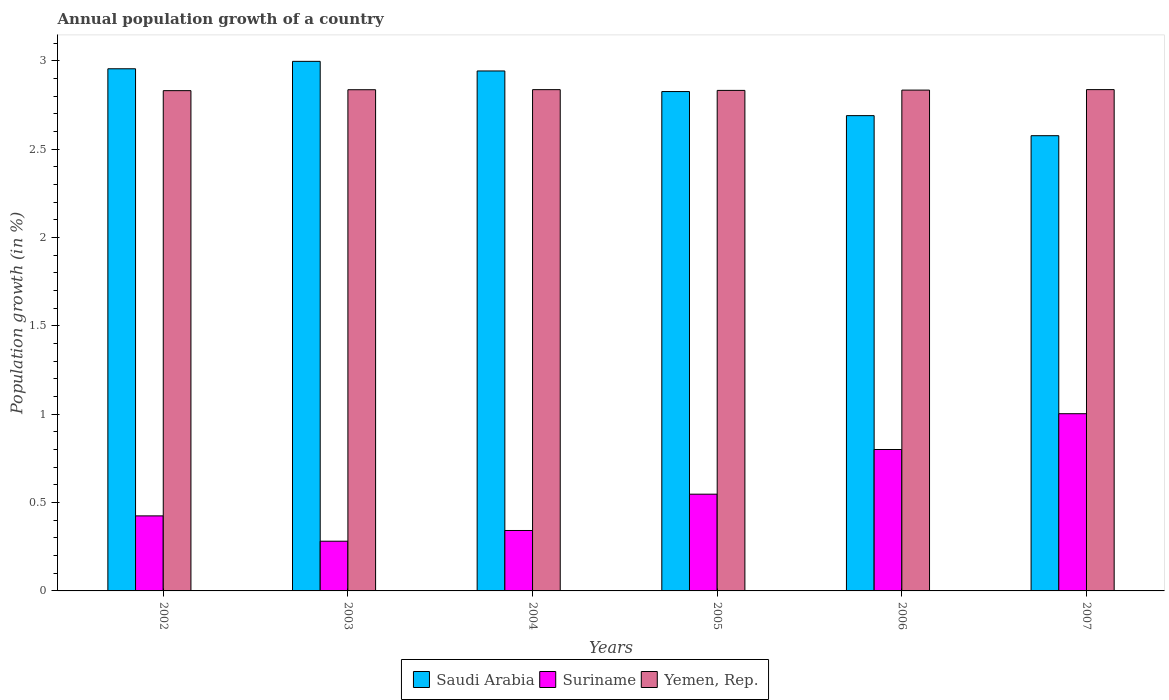Are the number of bars per tick equal to the number of legend labels?
Offer a terse response. Yes. How many bars are there on the 3rd tick from the left?
Provide a short and direct response. 3. How many bars are there on the 2nd tick from the right?
Keep it short and to the point. 3. In how many cases, is the number of bars for a given year not equal to the number of legend labels?
Provide a short and direct response. 0. What is the annual population growth in Suriname in 2003?
Your response must be concise. 0.28. Across all years, what is the maximum annual population growth in Saudi Arabia?
Ensure brevity in your answer.  3. Across all years, what is the minimum annual population growth in Yemen, Rep.?
Provide a succinct answer. 2.83. In which year was the annual population growth in Suriname maximum?
Provide a succinct answer. 2007. What is the total annual population growth in Yemen, Rep. in the graph?
Give a very brief answer. 17.01. What is the difference between the annual population growth in Saudi Arabia in 2004 and that in 2006?
Provide a short and direct response. 0.25. What is the difference between the annual population growth in Saudi Arabia in 2005 and the annual population growth in Suriname in 2006?
Give a very brief answer. 2.03. What is the average annual population growth in Saudi Arabia per year?
Provide a succinct answer. 2.83. In the year 2006, what is the difference between the annual population growth in Suriname and annual population growth in Yemen, Rep.?
Ensure brevity in your answer.  -2.03. What is the ratio of the annual population growth in Yemen, Rep. in 2005 to that in 2006?
Your answer should be very brief. 1. Is the annual population growth in Saudi Arabia in 2002 less than that in 2004?
Give a very brief answer. No. What is the difference between the highest and the second highest annual population growth in Saudi Arabia?
Offer a very short reply. 0.04. What is the difference between the highest and the lowest annual population growth in Saudi Arabia?
Your answer should be compact. 0.42. Is the sum of the annual population growth in Yemen, Rep. in 2003 and 2005 greater than the maximum annual population growth in Suriname across all years?
Offer a very short reply. Yes. What does the 2nd bar from the left in 2002 represents?
Keep it short and to the point. Suriname. What does the 3rd bar from the right in 2002 represents?
Your answer should be very brief. Saudi Arabia. How many years are there in the graph?
Provide a succinct answer. 6. What is the difference between two consecutive major ticks on the Y-axis?
Make the answer very short. 0.5. Are the values on the major ticks of Y-axis written in scientific E-notation?
Provide a succinct answer. No. Does the graph contain any zero values?
Provide a short and direct response. No. Does the graph contain grids?
Your answer should be compact. No. Where does the legend appear in the graph?
Your answer should be very brief. Bottom center. How are the legend labels stacked?
Offer a terse response. Horizontal. What is the title of the graph?
Ensure brevity in your answer.  Annual population growth of a country. Does "Suriname" appear as one of the legend labels in the graph?
Ensure brevity in your answer.  Yes. What is the label or title of the X-axis?
Offer a very short reply. Years. What is the label or title of the Y-axis?
Your response must be concise. Population growth (in %). What is the Population growth (in %) of Saudi Arabia in 2002?
Make the answer very short. 2.96. What is the Population growth (in %) of Suriname in 2002?
Your answer should be compact. 0.42. What is the Population growth (in %) of Yemen, Rep. in 2002?
Provide a succinct answer. 2.83. What is the Population growth (in %) in Saudi Arabia in 2003?
Provide a succinct answer. 3. What is the Population growth (in %) in Suriname in 2003?
Offer a very short reply. 0.28. What is the Population growth (in %) of Yemen, Rep. in 2003?
Offer a very short reply. 2.84. What is the Population growth (in %) in Saudi Arabia in 2004?
Give a very brief answer. 2.94. What is the Population growth (in %) of Suriname in 2004?
Your answer should be very brief. 0.34. What is the Population growth (in %) in Yemen, Rep. in 2004?
Keep it short and to the point. 2.84. What is the Population growth (in %) in Saudi Arabia in 2005?
Your answer should be very brief. 2.83. What is the Population growth (in %) in Suriname in 2005?
Ensure brevity in your answer.  0.55. What is the Population growth (in %) in Yemen, Rep. in 2005?
Provide a succinct answer. 2.83. What is the Population growth (in %) in Saudi Arabia in 2006?
Give a very brief answer. 2.69. What is the Population growth (in %) of Suriname in 2006?
Give a very brief answer. 0.8. What is the Population growth (in %) of Yemen, Rep. in 2006?
Give a very brief answer. 2.83. What is the Population growth (in %) in Saudi Arabia in 2007?
Offer a terse response. 2.58. What is the Population growth (in %) in Suriname in 2007?
Offer a very short reply. 1. What is the Population growth (in %) in Yemen, Rep. in 2007?
Keep it short and to the point. 2.84. Across all years, what is the maximum Population growth (in %) of Saudi Arabia?
Ensure brevity in your answer.  3. Across all years, what is the maximum Population growth (in %) of Suriname?
Offer a terse response. 1. Across all years, what is the maximum Population growth (in %) in Yemen, Rep.?
Give a very brief answer. 2.84. Across all years, what is the minimum Population growth (in %) in Saudi Arabia?
Make the answer very short. 2.58. Across all years, what is the minimum Population growth (in %) of Suriname?
Provide a short and direct response. 0.28. Across all years, what is the minimum Population growth (in %) of Yemen, Rep.?
Your response must be concise. 2.83. What is the total Population growth (in %) in Saudi Arabia in the graph?
Your response must be concise. 16.99. What is the total Population growth (in %) in Suriname in the graph?
Your response must be concise. 3.4. What is the total Population growth (in %) in Yemen, Rep. in the graph?
Offer a terse response. 17.01. What is the difference between the Population growth (in %) in Saudi Arabia in 2002 and that in 2003?
Make the answer very short. -0.04. What is the difference between the Population growth (in %) of Suriname in 2002 and that in 2003?
Make the answer very short. 0.14. What is the difference between the Population growth (in %) in Yemen, Rep. in 2002 and that in 2003?
Keep it short and to the point. -0.01. What is the difference between the Population growth (in %) in Saudi Arabia in 2002 and that in 2004?
Offer a terse response. 0.01. What is the difference between the Population growth (in %) of Suriname in 2002 and that in 2004?
Make the answer very short. 0.08. What is the difference between the Population growth (in %) in Yemen, Rep. in 2002 and that in 2004?
Keep it short and to the point. -0.01. What is the difference between the Population growth (in %) of Saudi Arabia in 2002 and that in 2005?
Give a very brief answer. 0.13. What is the difference between the Population growth (in %) in Suriname in 2002 and that in 2005?
Your answer should be very brief. -0.12. What is the difference between the Population growth (in %) of Yemen, Rep. in 2002 and that in 2005?
Make the answer very short. -0. What is the difference between the Population growth (in %) in Saudi Arabia in 2002 and that in 2006?
Offer a terse response. 0.27. What is the difference between the Population growth (in %) in Suriname in 2002 and that in 2006?
Your response must be concise. -0.38. What is the difference between the Population growth (in %) in Yemen, Rep. in 2002 and that in 2006?
Provide a succinct answer. -0. What is the difference between the Population growth (in %) of Saudi Arabia in 2002 and that in 2007?
Offer a terse response. 0.38. What is the difference between the Population growth (in %) of Suriname in 2002 and that in 2007?
Ensure brevity in your answer.  -0.58. What is the difference between the Population growth (in %) in Yemen, Rep. in 2002 and that in 2007?
Your response must be concise. -0.01. What is the difference between the Population growth (in %) in Saudi Arabia in 2003 and that in 2004?
Ensure brevity in your answer.  0.05. What is the difference between the Population growth (in %) in Suriname in 2003 and that in 2004?
Your response must be concise. -0.06. What is the difference between the Population growth (in %) in Yemen, Rep. in 2003 and that in 2004?
Ensure brevity in your answer.  -0. What is the difference between the Population growth (in %) of Saudi Arabia in 2003 and that in 2005?
Keep it short and to the point. 0.17. What is the difference between the Population growth (in %) in Suriname in 2003 and that in 2005?
Your answer should be compact. -0.27. What is the difference between the Population growth (in %) of Yemen, Rep. in 2003 and that in 2005?
Ensure brevity in your answer.  0. What is the difference between the Population growth (in %) of Saudi Arabia in 2003 and that in 2006?
Make the answer very short. 0.31. What is the difference between the Population growth (in %) in Suriname in 2003 and that in 2006?
Your answer should be very brief. -0.52. What is the difference between the Population growth (in %) of Yemen, Rep. in 2003 and that in 2006?
Ensure brevity in your answer.  0. What is the difference between the Population growth (in %) of Saudi Arabia in 2003 and that in 2007?
Ensure brevity in your answer.  0.42. What is the difference between the Population growth (in %) of Suriname in 2003 and that in 2007?
Offer a terse response. -0.72. What is the difference between the Population growth (in %) in Yemen, Rep. in 2003 and that in 2007?
Provide a succinct answer. -0. What is the difference between the Population growth (in %) in Saudi Arabia in 2004 and that in 2005?
Give a very brief answer. 0.12. What is the difference between the Population growth (in %) in Suriname in 2004 and that in 2005?
Offer a terse response. -0.21. What is the difference between the Population growth (in %) of Yemen, Rep. in 2004 and that in 2005?
Keep it short and to the point. 0. What is the difference between the Population growth (in %) in Saudi Arabia in 2004 and that in 2006?
Keep it short and to the point. 0.25. What is the difference between the Population growth (in %) of Suriname in 2004 and that in 2006?
Your answer should be very brief. -0.46. What is the difference between the Population growth (in %) in Yemen, Rep. in 2004 and that in 2006?
Provide a succinct answer. 0. What is the difference between the Population growth (in %) of Saudi Arabia in 2004 and that in 2007?
Your answer should be compact. 0.37. What is the difference between the Population growth (in %) of Suriname in 2004 and that in 2007?
Offer a terse response. -0.66. What is the difference between the Population growth (in %) of Yemen, Rep. in 2004 and that in 2007?
Ensure brevity in your answer.  -0. What is the difference between the Population growth (in %) of Saudi Arabia in 2005 and that in 2006?
Keep it short and to the point. 0.14. What is the difference between the Population growth (in %) in Suriname in 2005 and that in 2006?
Provide a short and direct response. -0.25. What is the difference between the Population growth (in %) of Yemen, Rep. in 2005 and that in 2006?
Your response must be concise. -0. What is the difference between the Population growth (in %) of Saudi Arabia in 2005 and that in 2007?
Keep it short and to the point. 0.25. What is the difference between the Population growth (in %) of Suriname in 2005 and that in 2007?
Your answer should be very brief. -0.46. What is the difference between the Population growth (in %) in Yemen, Rep. in 2005 and that in 2007?
Ensure brevity in your answer.  -0. What is the difference between the Population growth (in %) of Saudi Arabia in 2006 and that in 2007?
Provide a short and direct response. 0.11. What is the difference between the Population growth (in %) of Suriname in 2006 and that in 2007?
Provide a succinct answer. -0.2. What is the difference between the Population growth (in %) of Yemen, Rep. in 2006 and that in 2007?
Provide a short and direct response. -0. What is the difference between the Population growth (in %) of Saudi Arabia in 2002 and the Population growth (in %) of Suriname in 2003?
Make the answer very short. 2.67. What is the difference between the Population growth (in %) in Saudi Arabia in 2002 and the Population growth (in %) in Yemen, Rep. in 2003?
Keep it short and to the point. 0.12. What is the difference between the Population growth (in %) of Suriname in 2002 and the Population growth (in %) of Yemen, Rep. in 2003?
Give a very brief answer. -2.41. What is the difference between the Population growth (in %) of Saudi Arabia in 2002 and the Population growth (in %) of Suriname in 2004?
Provide a short and direct response. 2.61. What is the difference between the Population growth (in %) in Saudi Arabia in 2002 and the Population growth (in %) in Yemen, Rep. in 2004?
Offer a very short reply. 0.12. What is the difference between the Population growth (in %) of Suriname in 2002 and the Population growth (in %) of Yemen, Rep. in 2004?
Your response must be concise. -2.41. What is the difference between the Population growth (in %) of Saudi Arabia in 2002 and the Population growth (in %) of Suriname in 2005?
Provide a succinct answer. 2.41. What is the difference between the Population growth (in %) in Saudi Arabia in 2002 and the Population growth (in %) in Yemen, Rep. in 2005?
Provide a short and direct response. 0.12. What is the difference between the Population growth (in %) in Suriname in 2002 and the Population growth (in %) in Yemen, Rep. in 2005?
Your answer should be compact. -2.41. What is the difference between the Population growth (in %) in Saudi Arabia in 2002 and the Population growth (in %) in Suriname in 2006?
Ensure brevity in your answer.  2.16. What is the difference between the Population growth (in %) of Saudi Arabia in 2002 and the Population growth (in %) of Yemen, Rep. in 2006?
Offer a terse response. 0.12. What is the difference between the Population growth (in %) of Suriname in 2002 and the Population growth (in %) of Yemen, Rep. in 2006?
Your answer should be compact. -2.41. What is the difference between the Population growth (in %) in Saudi Arabia in 2002 and the Population growth (in %) in Suriname in 2007?
Make the answer very short. 1.95. What is the difference between the Population growth (in %) in Saudi Arabia in 2002 and the Population growth (in %) in Yemen, Rep. in 2007?
Give a very brief answer. 0.12. What is the difference between the Population growth (in %) in Suriname in 2002 and the Population growth (in %) in Yemen, Rep. in 2007?
Provide a succinct answer. -2.41. What is the difference between the Population growth (in %) in Saudi Arabia in 2003 and the Population growth (in %) in Suriname in 2004?
Offer a terse response. 2.66. What is the difference between the Population growth (in %) in Saudi Arabia in 2003 and the Population growth (in %) in Yemen, Rep. in 2004?
Keep it short and to the point. 0.16. What is the difference between the Population growth (in %) of Suriname in 2003 and the Population growth (in %) of Yemen, Rep. in 2004?
Your answer should be compact. -2.56. What is the difference between the Population growth (in %) in Saudi Arabia in 2003 and the Population growth (in %) in Suriname in 2005?
Ensure brevity in your answer.  2.45. What is the difference between the Population growth (in %) of Saudi Arabia in 2003 and the Population growth (in %) of Yemen, Rep. in 2005?
Your answer should be compact. 0.16. What is the difference between the Population growth (in %) in Suriname in 2003 and the Population growth (in %) in Yemen, Rep. in 2005?
Provide a succinct answer. -2.55. What is the difference between the Population growth (in %) in Saudi Arabia in 2003 and the Population growth (in %) in Suriname in 2006?
Provide a succinct answer. 2.2. What is the difference between the Population growth (in %) of Saudi Arabia in 2003 and the Population growth (in %) of Yemen, Rep. in 2006?
Keep it short and to the point. 0.16. What is the difference between the Population growth (in %) of Suriname in 2003 and the Population growth (in %) of Yemen, Rep. in 2006?
Give a very brief answer. -2.55. What is the difference between the Population growth (in %) in Saudi Arabia in 2003 and the Population growth (in %) in Suriname in 2007?
Provide a short and direct response. 1.99. What is the difference between the Population growth (in %) in Saudi Arabia in 2003 and the Population growth (in %) in Yemen, Rep. in 2007?
Offer a very short reply. 0.16. What is the difference between the Population growth (in %) of Suriname in 2003 and the Population growth (in %) of Yemen, Rep. in 2007?
Ensure brevity in your answer.  -2.56. What is the difference between the Population growth (in %) of Saudi Arabia in 2004 and the Population growth (in %) of Suriname in 2005?
Make the answer very short. 2.4. What is the difference between the Population growth (in %) of Saudi Arabia in 2004 and the Population growth (in %) of Yemen, Rep. in 2005?
Offer a terse response. 0.11. What is the difference between the Population growth (in %) in Suriname in 2004 and the Population growth (in %) in Yemen, Rep. in 2005?
Provide a short and direct response. -2.49. What is the difference between the Population growth (in %) of Saudi Arabia in 2004 and the Population growth (in %) of Suriname in 2006?
Your response must be concise. 2.14. What is the difference between the Population growth (in %) in Saudi Arabia in 2004 and the Population growth (in %) in Yemen, Rep. in 2006?
Ensure brevity in your answer.  0.11. What is the difference between the Population growth (in %) in Suriname in 2004 and the Population growth (in %) in Yemen, Rep. in 2006?
Offer a very short reply. -2.49. What is the difference between the Population growth (in %) in Saudi Arabia in 2004 and the Population growth (in %) in Suriname in 2007?
Your response must be concise. 1.94. What is the difference between the Population growth (in %) in Saudi Arabia in 2004 and the Population growth (in %) in Yemen, Rep. in 2007?
Offer a terse response. 0.11. What is the difference between the Population growth (in %) of Suriname in 2004 and the Population growth (in %) of Yemen, Rep. in 2007?
Ensure brevity in your answer.  -2.5. What is the difference between the Population growth (in %) of Saudi Arabia in 2005 and the Population growth (in %) of Suriname in 2006?
Offer a terse response. 2.03. What is the difference between the Population growth (in %) in Saudi Arabia in 2005 and the Population growth (in %) in Yemen, Rep. in 2006?
Your answer should be very brief. -0.01. What is the difference between the Population growth (in %) in Suriname in 2005 and the Population growth (in %) in Yemen, Rep. in 2006?
Offer a terse response. -2.29. What is the difference between the Population growth (in %) in Saudi Arabia in 2005 and the Population growth (in %) in Suriname in 2007?
Give a very brief answer. 1.82. What is the difference between the Population growth (in %) of Saudi Arabia in 2005 and the Population growth (in %) of Yemen, Rep. in 2007?
Give a very brief answer. -0.01. What is the difference between the Population growth (in %) in Suriname in 2005 and the Population growth (in %) in Yemen, Rep. in 2007?
Offer a terse response. -2.29. What is the difference between the Population growth (in %) in Saudi Arabia in 2006 and the Population growth (in %) in Suriname in 2007?
Your answer should be very brief. 1.69. What is the difference between the Population growth (in %) of Saudi Arabia in 2006 and the Population growth (in %) of Yemen, Rep. in 2007?
Provide a short and direct response. -0.15. What is the difference between the Population growth (in %) in Suriname in 2006 and the Population growth (in %) in Yemen, Rep. in 2007?
Provide a succinct answer. -2.04. What is the average Population growth (in %) in Saudi Arabia per year?
Your response must be concise. 2.83. What is the average Population growth (in %) of Suriname per year?
Keep it short and to the point. 0.57. What is the average Population growth (in %) in Yemen, Rep. per year?
Your answer should be compact. 2.84. In the year 2002, what is the difference between the Population growth (in %) in Saudi Arabia and Population growth (in %) in Suriname?
Your answer should be compact. 2.53. In the year 2002, what is the difference between the Population growth (in %) of Saudi Arabia and Population growth (in %) of Yemen, Rep.?
Offer a terse response. 0.12. In the year 2002, what is the difference between the Population growth (in %) of Suriname and Population growth (in %) of Yemen, Rep.?
Your answer should be very brief. -2.41. In the year 2003, what is the difference between the Population growth (in %) in Saudi Arabia and Population growth (in %) in Suriname?
Your answer should be compact. 2.72. In the year 2003, what is the difference between the Population growth (in %) in Saudi Arabia and Population growth (in %) in Yemen, Rep.?
Your answer should be compact. 0.16. In the year 2003, what is the difference between the Population growth (in %) of Suriname and Population growth (in %) of Yemen, Rep.?
Provide a succinct answer. -2.56. In the year 2004, what is the difference between the Population growth (in %) in Saudi Arabia and Population growth (in %) in Suriname?
Provide a succinct answer. 2.6. In the year 2004, what is the difference between the Population growth (in %) of Saudi Arabia and Population growth (in %) of Yemen, Rep.?
Give a very brief answer. 0.11. In the year 2004, what is the difference between the Population growth (in %) of Suriname and Population growth (in %) of Yemen, Rep.?
Your answer should be very brief. -2.5. In the year 2005, what is the difference between the Population growth (in %) in Saudi Arabia and Population growth (in %) in Suriname?
Keep it short and to the point. 2.28. In the year 2005, what is the difference between the Population growth (in %) of Saudi Arabia and Population growth (in %) of Yemen, Rep.?
Provide a succinct answer. -0.01. In the year 2005, what is the difference between the Population growth (in %) of Suriname and Population growth (in %) of Yemen, Rep.?
Give a very brief answer. -2.29. In the year 2006, what is the difference between the Population growth (in %) in Saudi Arabia and Population growth (in %) in Suriname?
Ensure brevity in your answer.  1.89. In the year 2006, what is the difference between the Population growth (in %) of Saudi Arabia and Population growth (in %) of Yemen, Rep.?
Your response must be concise. -0.14. In the year 2006, what is the difference between the Population growth (in %) in Suriname and Population growth (in %) in Yemen, Rep.?
Make the answer very short. -2.03. In the year 2007, what is the difference between the Population growth (in %) in Saudi Arabia and Population growth (in %) in Suriname?
Make the answer very short. 1.57. In the year 2007, what is the difference between the Population growth (in %) in Saudi Arabia and Population growth (in %) in Yemen, Rep.?
Make the answer very short. -0.26. In the year 2007, what is the difference between the Population growth (in %) in Suriname and Population growth (in %) in Yemen, Rep.?
Provide a succinct answer. -1.83. What is the ratio of the Population growth (in %) of Suriname in 2002 to that in 2003?
Keep it short and to the point. 1.51. What is the ratio of the Population growth (in %) of Yemen, Rep. in 2002 to that in 2003?
Offer a very short reply. 1. What is the ratio of the Population growth (in %) in Suriname in 2002 to that in 2004?
Ensure brevity in your answer.  1.24. What is the ratio of the Population growth (in %) of Yemen, Rep. in 2002 to that in 2004?
Ensure brevity in your answer.  1. What is the ratio of the Population growth (in %) in Saudi Arabia in 2002 to that in 2005?
Provide a short and direct response. 1.05. What is the ratio of the Population growth (in %) in Suriname in 2002 to that in 2005?
Your response must be concise. 0.78. What is the ratio of the Population growth (in %) in Saudi Arabia in 2002 to that in 2006?
Provide a succinct answer. 1.1. What is the ratio of the Population growth (in %) in Suriname in 2002 to that in 2006?
Ensure brevity in your answer.  0.53. What is the ratio of the Population growth (in %) in Saudi Arabia in 2002 to that in 2007?
Your answer should be compact. 1.15. What is the ratio of the Population growth (in %) in Suriname in 2002 to that in 2007?
Give a very brief answer. 0.42. What is the ratio of the Population growth (in %) of Saudi Arabia in 2003 to that in 2004?
Offer a very short reply. 1.02. What is the ratio of the Population growth (in %) of Suriname in 2003 to that in 2004?
Keep it short and to the point. 0.82. What is the ratio of the Population growth (in %) in Saudi Arabia in 2003 to that in 2005?
Give a very brief answer. 1.06. What is the ratio of the Population growth (in %) in Suriname in 2003 to that in 2005?
Provide a short and direct response. 0.51. What is the ratio of the Population growth (in %) in Yemen, Rep. in 2003 to that in 2005?
Offer a terse response. 1. What is the ratio of the Population growth (in %) in Saudi Arabia in 2003 to that in 2006?
Make the answer very short. 1.11. What is the ratio of the Population growth (in %) of Suriname in 2003 to that in 2006?
Give a very brief answer. 0.35. What is the ratio of the Population growth (in %) in Saudi Arabia in 2003 to that in 2007?
Your answer should be very brief. 1.16. What is the ratio of the Population growth (in %) in Suriname in 2003 to that in 2007?
Your response must be concise. 0.28. What is the ratio of the Population growth (in %) of Yemen, Rep. in 2003 to that in 2007?
Offer a very short reply. 1. What is the ratio of the Population growth (in %) in Saudi Arabia in 2004 to that in 2005?
Ensure brevity in your answer.  1.04. What is the ratio of the Population growth (in %) of Suriname in 2004 to that in 2005?
Ensure brevity in your answer.  0.62. What is the ratio of the Population growth (in %) of Saudi Arabia in 2004 to that in 2006?
Keep it short and to the point. 1.09. What is the ratio of the Population growth (in %) of Suriname in 2004 to that in 2006?
Make the answer very short. 0.43. What is the ratio of the Population growth (in %) of Saudi Arabia in 2004 to that in 2007?
Provide a short and direct response. 1.14. What is the ratio of the Population growth (in %) in Suriname in 2004 to that in 2007?
Provide a succinct answer. 0.34. What is the ratio of the Population growth (in %) in Saudi Arabia in 2005 to that in 2006?
Keep it short and to the point. 1.05. What is the ratio of the Population growth (in %) in Suriname in 2005 to that in 2006?
Ensure brevity in your answer.  0.68. What is the ratio of the Population growth (in %) in Saudi Arabia in 2005 to that in 2007?
Give a very brief answer. 1.1. What is the ratio of the Population growth (in %) of Suriname in 2005 to that in 2007?
Give a very brief answer. 0.55. What is the ratio of the Population growth (in %) in Saudi Arabia in 2006 to that in 2007?
Provide a short and direct response. 1.04. What is the ratio of the Population growth (in %) of Suriname in 2006 to that in 2007?
Provide a succinct answer. 0.8. What is the difference between the highest and the second highest Population growth (in %) in Saudi Arabia?
Provide a short and direct response. 0.04. What is the difference between the highest and the second highest Population growth (in %) of Suriname?
Keep it short and to the point. 0.2. What is the difference between the highest and the lowest Population growth (in %) of Saudi Arabia?
Provide a succinct answer. 0.42. What is the difference between the highest and the lowest Population growth (in %) in Suriname?
Offer a terse response. 0.72. What is the difference between the highest and the lowest Population growth (in %) of Yemen, Rep.?
Your answer should be very brief. 0.01. 